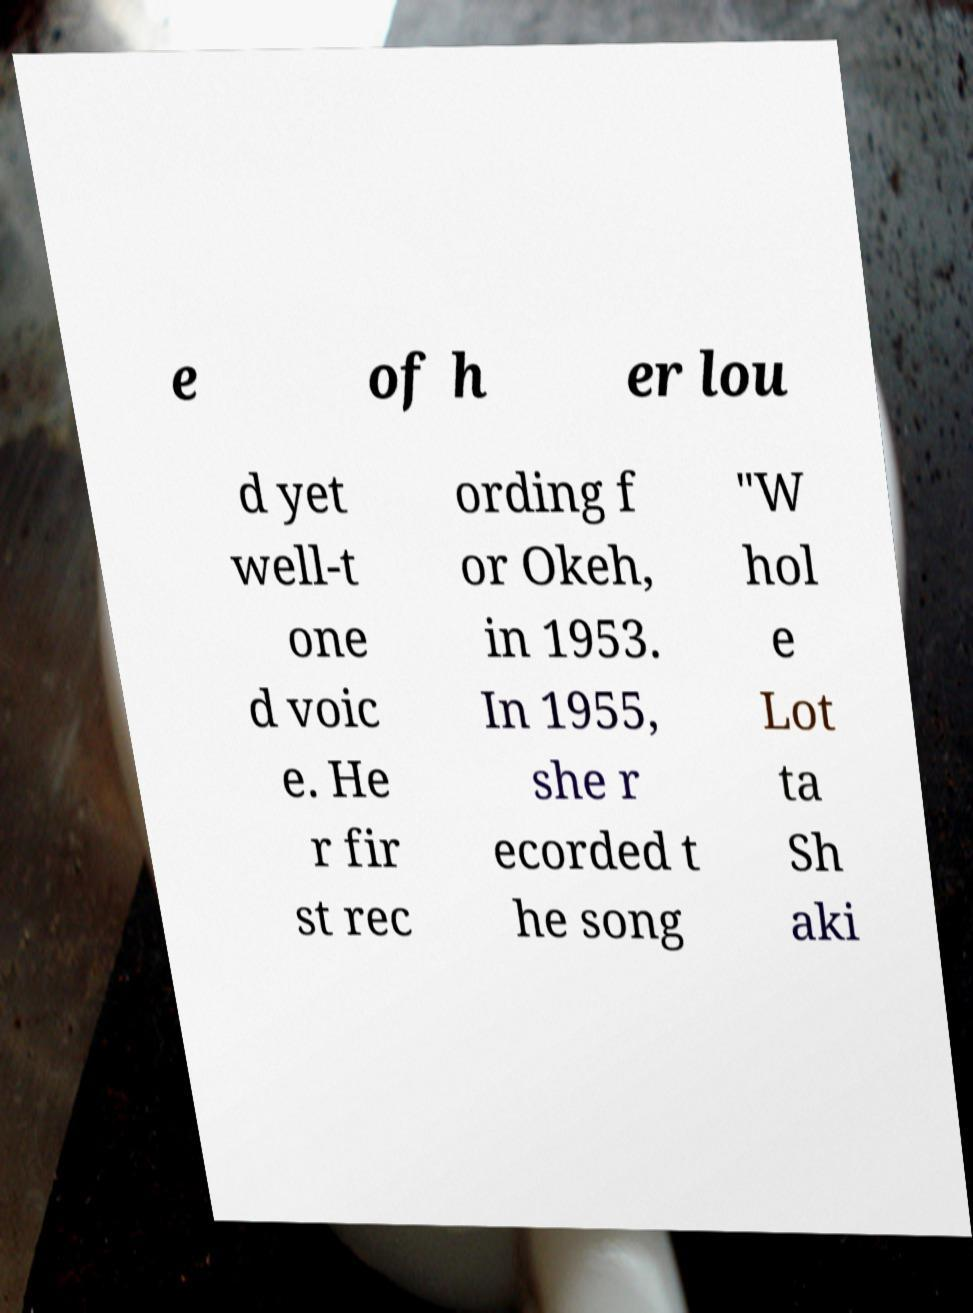Please identify and transcribe the text found in this image. e of h er lou d yet well-t one d voic e. He r fir st rec ording f or Okeh, in 1953. In 1955, she r ecorded t he song "W hol e Lot ta Sh aki 